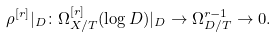Convert formula to latex. <formula><loc_0><loc_0><loc_500><loc_500>\rho ^ { [ r ] } | _ { D } \colon \Omega _ { X / T } ^ { [ r ] } ( \log D ) | _ { D } \to \Omega ^ { r - 1 } _ { D / T } \to 0 .</formula> 